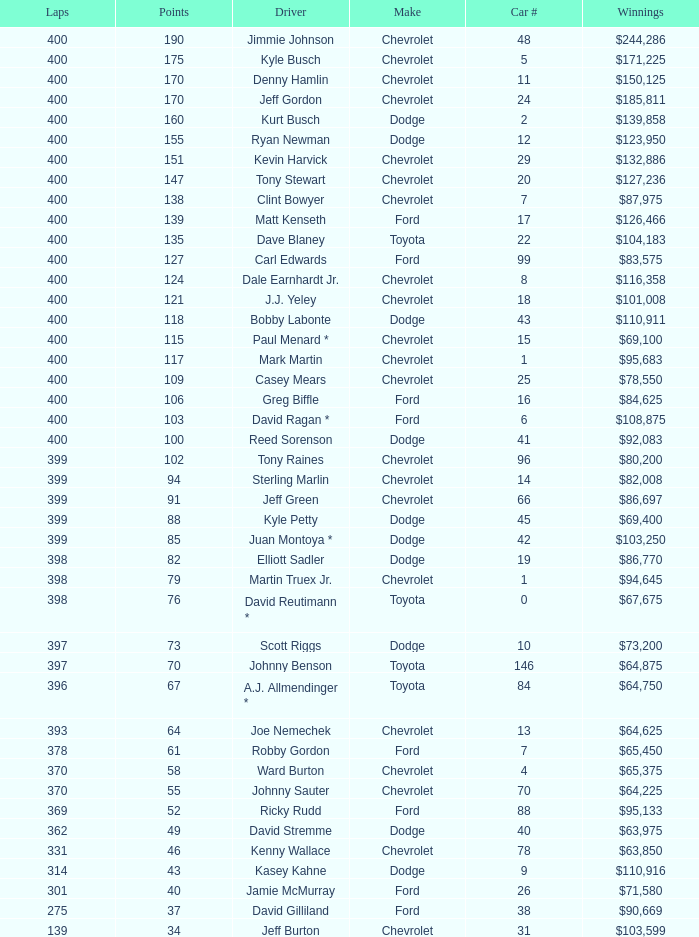What is the make of car 31? Chevrolet. Could you parse the entire table? {'header': ['Laps', 'Points', 'Driver', 'Make', 'Car #', 'Winnings'], 'rows': [['400', '190', 'Jimmie Johnson', 'Chevrolet', '48', '$244,286'], ['400', '175', 'Kyle Busch', 'Chevrolet', '5', '$171,225'], ['400', '170', 'Denny Hamlin', 'Chevrolet', '11', '$150,125'], ['400', '170', 'Jeff Gordon', 'Chevrolet', '24', '$185,811'], ['400', '160', 'Kurt Busch', 'Dodge', '2', '$139,858'], ['400', '155', 'Ryan Newman', 'Dodge', '12', '$123,950'], ['400', '151', 'Kevin Harvick', 'Chevrolet', '29', '$132,886'], ['400', '147', 'Tony Stewart', 'Chevrolet', '20', '$127,236'], ['400', '138', 'Clint Bowyer', 'Chevrolet', '7', '$87,975'], ['400', '139', 'Matt Kenseth', 'Ford', '17', '$126,466'], ['400', '135', 'Dave Blaney', 'Toyota', '22', '$104,183'], ['400', '127', 'Carl Edwards', 'Ford', '99', '$83,575'], ['400', '124', 'Dale Earnhardt Jr.', 'Chevrolet', '8', '$116,358'], ['400', '121', 'J.J. Yeley', 'Chevrolet', '18', '$101,008'], ['400', '118', 'Bobby Labonte', 'Dodge', '43', '$110,911'], ['400', '115', 'Paul Menard *', 'Chevrolet', '15', '$69,100'], ['400', '117', 'Mark Martin', 'Chevrolet', '1', '$95,683'], ['400', '109', 'Casey Mears', 'Chevrolet', '25', '$78,550'], ['400', '106', 'Greg Biffle', 'Ford', '16', '$84,625'], ['400', '103', 'David Ragan *', 'Ford', '6', '$108,875'], ['400', '100', 'Reed Sorenson', 'Dodge', '41', '$92,083'], ['399', '102', 'Tony Raines', 'Chevrolet', '96', '$80,200'], ['399', '94', 'Sterling Marlin', 'Chevrolet', '14', '$82,008'], ['399', '91', 'Jeff Green', 'Chevrolet', '66', '$86,697'], ['399', '88', 'Kyle Petty', 'Dodge', '45', '$69,400'], ['399', '85', 'Juan Montoya *', 'Dodge', '42', '$103,250'], ['398', '82', 'Elliott Sadler', 'Dodge', '19', '$86,770'], ['398', '79', 'Martin Truex Jr.', 'Chevrolet', '1', '$94,645'], ['398', '76', 'David Reutimann *', 'Toyota', '0', '$67,675'], ['397', '73', 'Scott Riggs', 'Dodge', '10', '$73,200'], ['397', '70', 'Johnny Benson', 'Toyota', '146', '$64,875'], ['396', '67', 'A.J. Allmendinger *', 'Toyota', '84', '$64,750'], ['393', '64', 'Joe Nemechek', 'Chevrolet', '13', '$64,625'], ['378', '61', 'Robby Gordon', 'Ford', '7', '$65,450'], ['370', '58', 'Ward Burton', 'Chevrolet', '4', '$65,375'], ['370', '55', 'Johnny Sauter', 'Chevrolet', '70', '$64,225'], ['369', '52', 'Ricky Rudd', 'Ford', '88', '$95,133'], ['362', '49', 'David Stremme', 'Dodge', '40', '$63,975'], ['331', '46', 'Kenny Wallace', 'Chevrolet', '78', '$63,850'], ['314', '43', 'Kasey Kahne', 'Dodge', '9', '$110,916'], ['301', '40', 'Jamie McMurray', 'Ford', '26', '$71,580'], ['275', '37', 'David Gilliland', 'Ford', '38', '$90,669'], ['139', '34', 'Jeff Burton', 'Chevrolet', '31', '$103,599']]} 